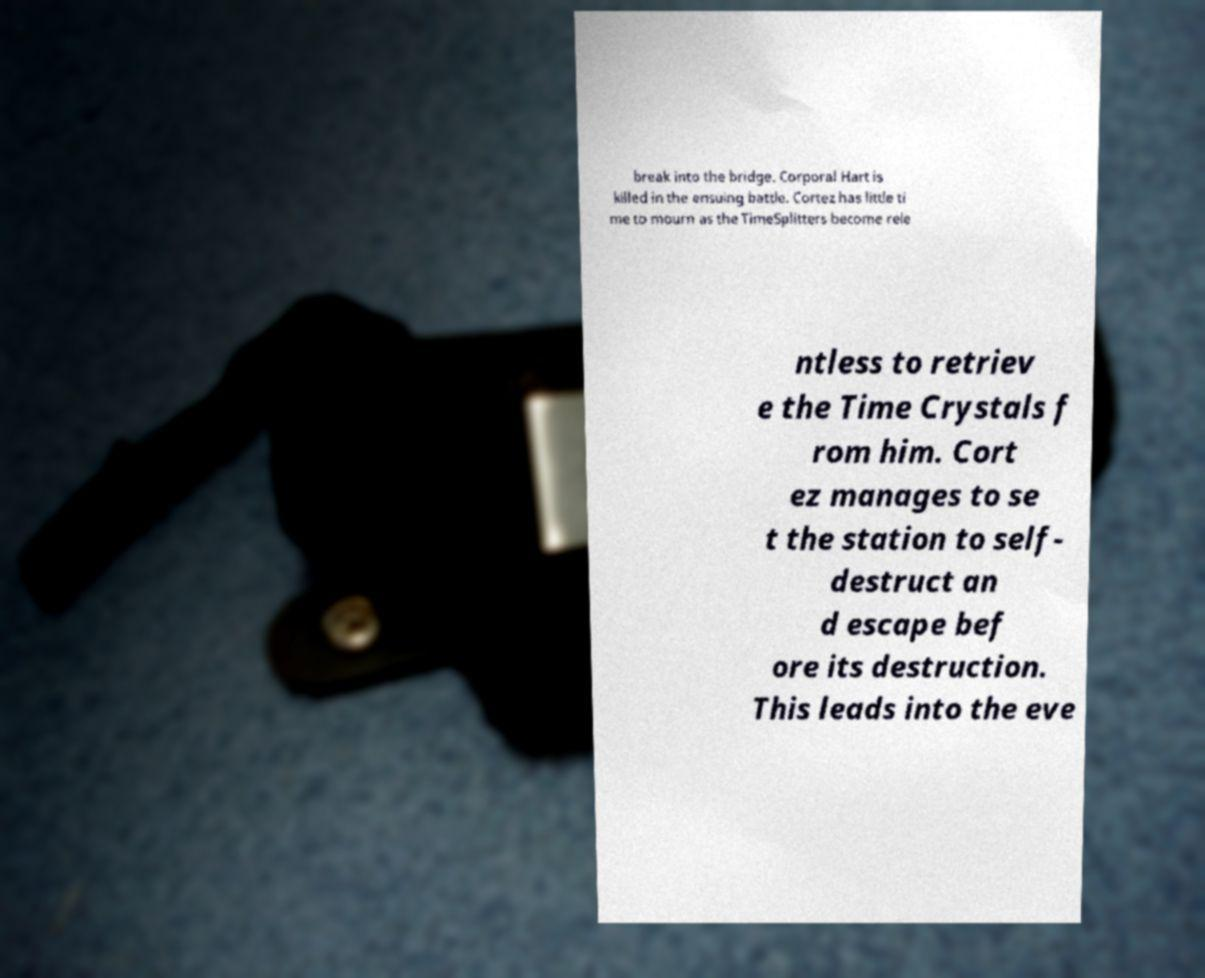Can you accurately transcribe the text from the provided image for me? break into the bridge. Corporal Hart is killed in the ensuing battle. Cortez has little ti me to mourn as the TimeSplitters become rele ntless to retriev e the Time Crystals f rom him. Cort ez manages to se t the station to self- destruct an d escape bef ore its destruction. This leads into the eve 